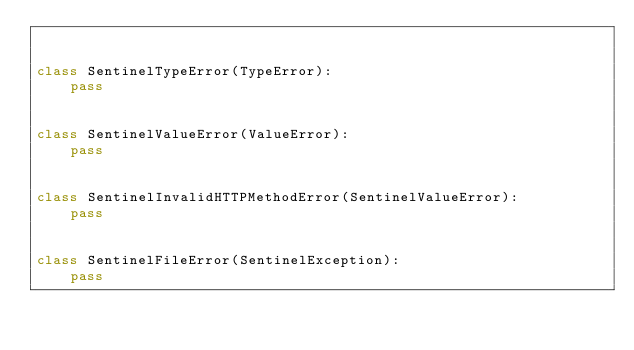<code> <loc_0><loc_0><loc_500><loc_500><_Python_>

class SentinelTypeError(TypeError):
    pass


class SentinelValueError(ValueError):
    pass


class SentinelInvalidHTTPMethodError(SentinelValueError):
    pass


class SentinelFileError(SentinelException):
    pass
</code> 